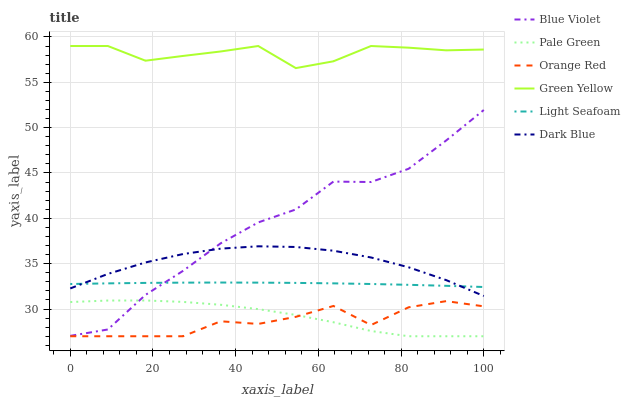Does Orange Red have the minimum area under the curve?
Answer yes or no. Yes. Does Dark Blue have the minimum area under the curve?
Answer yes or no. No. Does Dark Blue have the maximum area under the curve?
Answer yes or no. No. Is Orange Red the roughest?
Answer yes or no. Yes. Is Dark Blue the smoothest?
Answer yes or no. No. Is Dark Blue the roughest?
Answer yes or no. No. Does Dark Blue have the lowest value?
Answer yes or no. No. Does Dark Blue have the highest value?
Answer yes or no. No. Is Orange Red less than Dark Blue?
Answer yes or no. Yes. Is Green Yellow greater than Dark Blue?
Answer yes or no. Yes. Does Orange Red intersect Dark Blue?
Answer yes or no. No. 